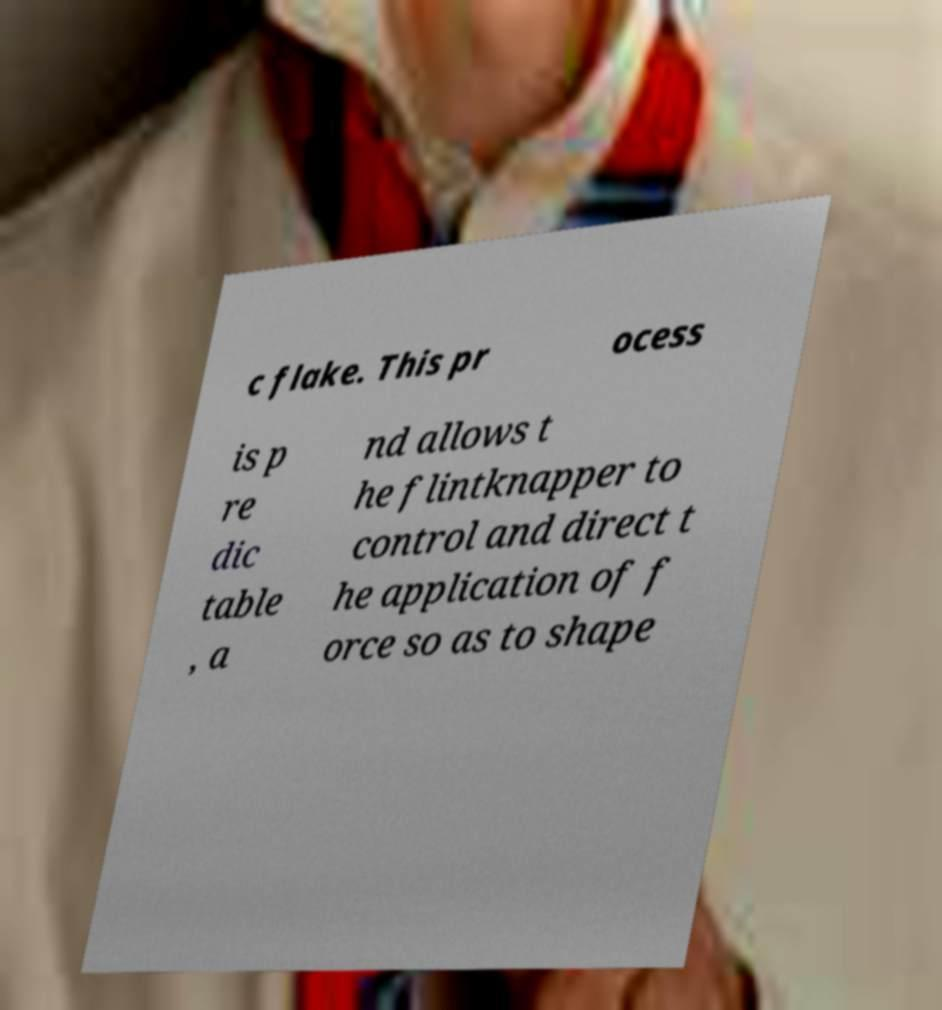Please identify and transcribe the text found in this image. c flake. This pr ocess is p re dic table , a nd allows t he flintknapper to control and direct t he application of f orce so as to shape 